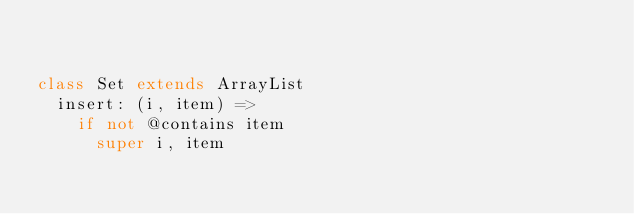<code> <loc_0><loc_0><loc_500><loc_500><_MoonScript_>

class Set extends ArrayList
	insert: (i, item) =>
		if not @contains item
			super i, item

</code> 